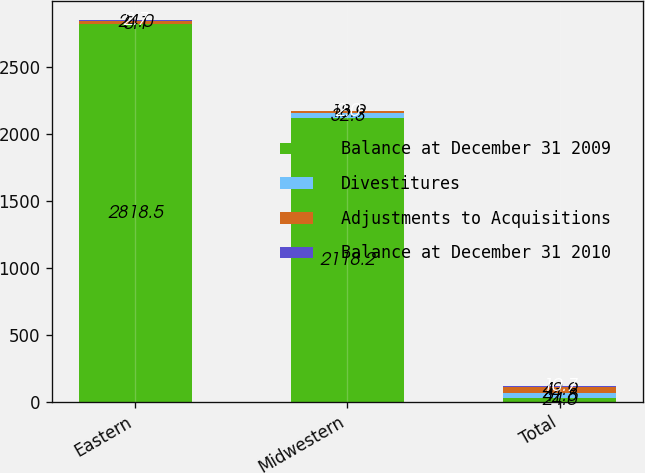Convert chart. <chart><loc_0><loc_0><loc_500><loc_500><stacked_bar_chart><ecel><fcel>Eastern<fcel>Midwestern<fcel>Total<nl><fcel>Balance at December 31 2009<fcel>2818.5<fcel>2118.2<fcel>24<nl><fcel>Divestitures<fcel>0.1<fcel>32.3<fcel>41.8<nl><fcel>Adjustments to Acquisitions<fcel>24<fcel>18.9<fcel>42.9<nl><fcel>Balance at December 31 2010<fcel>2.7<fcel>2<fcel>10.7<nl></chart> 